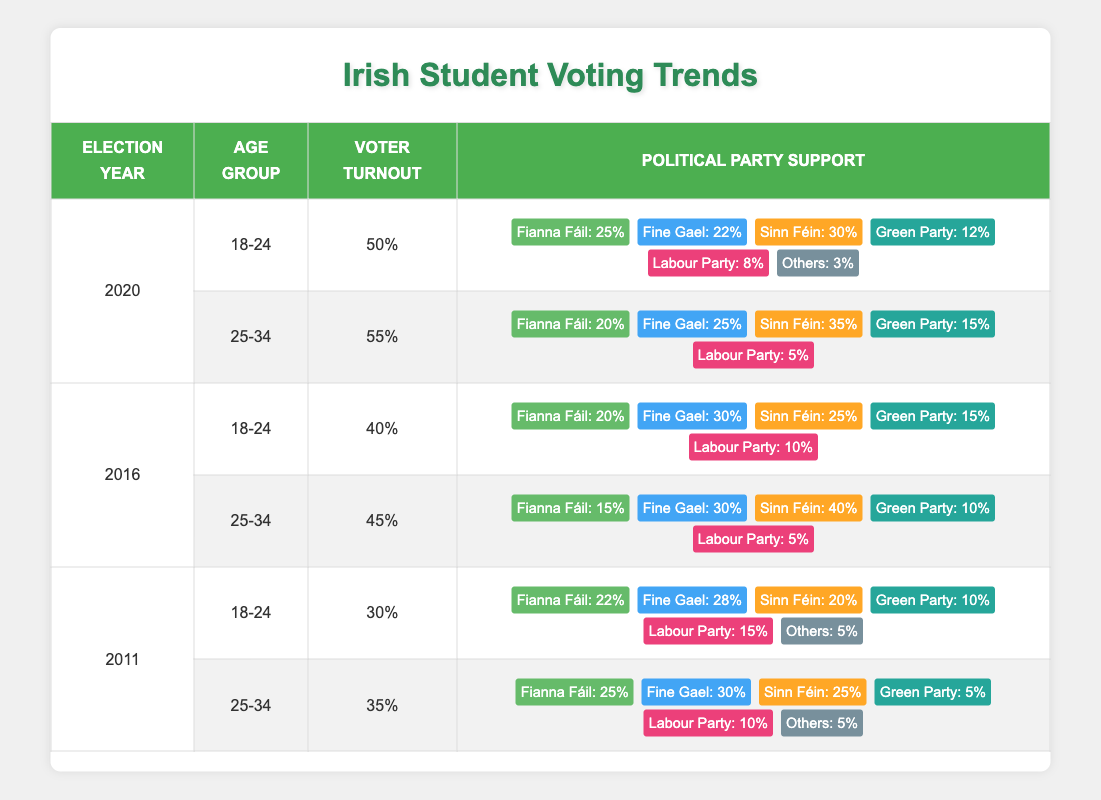What was the voter turnout percentage for the 18-24 age group in the 2020 election? The table shows the voter turnout percentage for the 18-24 age group in the 2020 election listed as 50%.
Answer: 50% Which political party had the highest support among the 25-34 age group in the 2016 election? By examining the political party support for the 25-34 age group in the 2016 election, Sinn Féin has the highest support at 40%.
Answer: Sinn Féin What is the average voter turnout across all elections for the 18-24 age group? The voter turnout percentages for the 18-24 age group are 50%, 40%, and 30% for the years 2020, 2016, and 2011 respectively. Their sum is 120%, and dividing by 3 gives an average of 40%.
Answer: 40% Did more than half of the 25-34 age group vote in the 2020 elections? The voter turnout for the 25-34 age group in the 2020 elections is 55%, which is greater than 50%.
Answer: Yes How much did the voter turnout for the 18-24 age group increase from 2011 to 2020? In 2011, the turnout was 30%, and in 2020, it was 50%. The increase is 50% - 30% = 20%.
Answer: 20% Which party saw a decrease in support from the 25-34 age group from 2011 (35%) to 2020 (55%)? The analysis shows that Fine Gael had a support of 30% in 2011 and 25% in 2020. Thus, it saw a decrease of 5%.
Answer: Fine Gael What percentage of 18-24 year olds voted for Sinn Féin in the 2020 election? In the 2020 election, the support for Sinn Féin among the 18-24 age group was 30%.
Answer: 30% Is it true that the voter turnout for the 25-34 age group decreased from 2011 to 2016? The turnout for 25-34 year-olds was 35% in 2011 and 45% in 2016, indicating an increase, so the statement is false.
Answer: No How does the voter turnout for the 18-24 age group in 2016 compare to that in 2020? The voter turnout for the 18-24 age group was 40% in 2016 and increased to 50% in 2020, indicating an increase.
Answer: Increase 